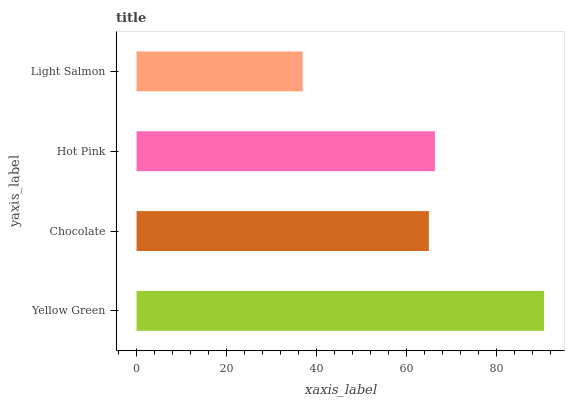Is Light Salmon the minimum?
Answer yes or no. Yes. Is Yellow Green the maximum?
Answer yes or no. Yes. Is Chocolate the minimum?
Answer yes or no. No. Is Chocolate the maximum?
Answer yes or no. No. Is Yellow Green greater than Chocolate?
Answer yes or no. Yes. Is Chocolate less than Yellow Green?
Answer yes or no. Yes. Is Chocolate greater than Yellow Green?
Answer yes or no. No. Is Yellow Green less than Chocolate?
Answer yes or no. No. Is Hot Pink the high median?
Answer yes or no. Yes. Is Chocolate the low median?
Answer yes or no. Yes. Is Yellow Green the high median?
Answer yes or no. No. Is Light Salmon the low median?
Answer yes or no. No. 